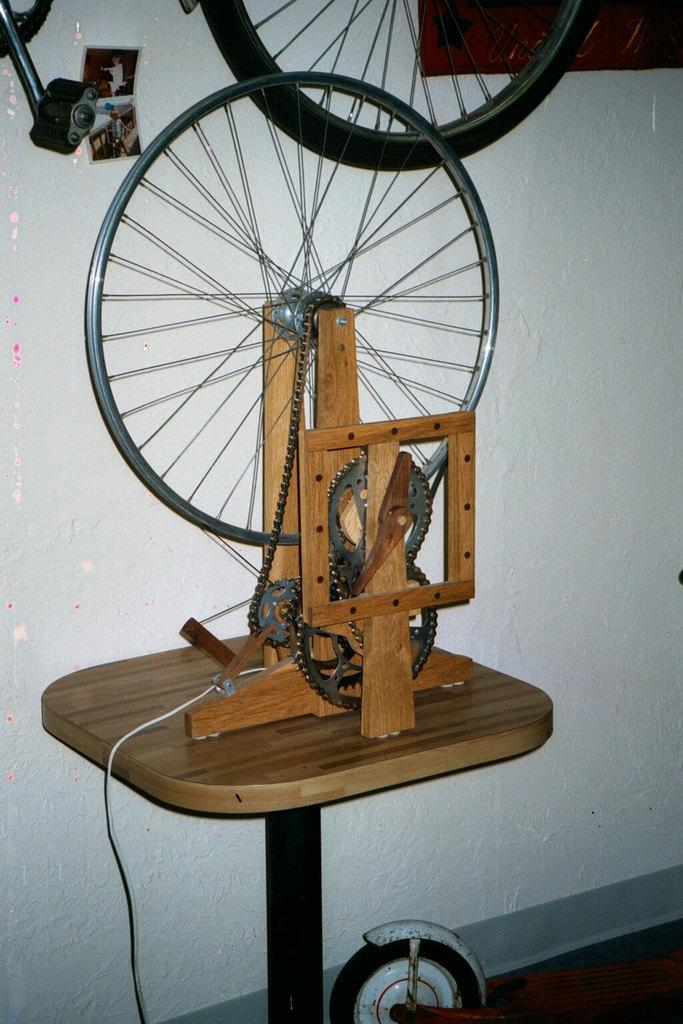What is the main object in the image? There is a cycle wheel in the image. How are the wheels connected in the image? The cycle wheel is connected to other wheels with a chain. What can be seen in the background of the image? There is a wall visible in the image. What type of juice is being squeezed by the woman in the image? There is no woman or juice present in the image; it only features a cycle wheel and connected wheels. 